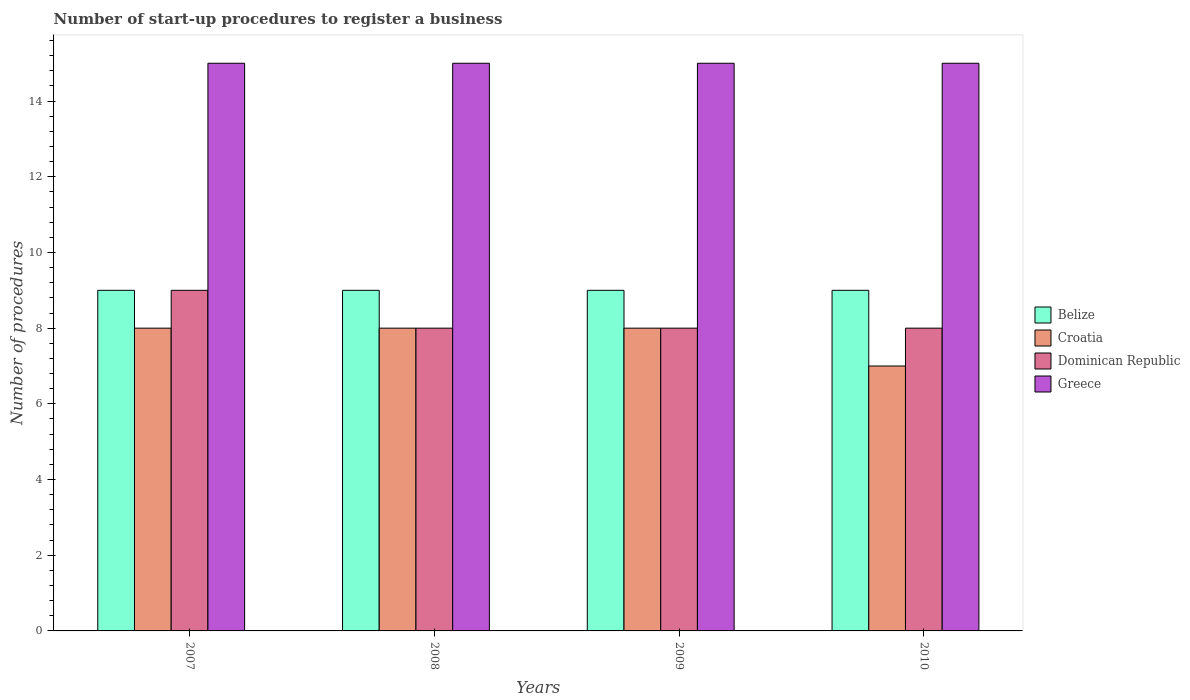How many different coloured bars are there?
Offer a terse response. 4. How many groups of bars are there?
Provide a short and direct response. 4. Are the number of bars per tick equal to the number of legend labels?
Ensure brevity in your answer.  Yes. Are the number of bars on each tick of the X-axis equal?
Provide a short and direct response. Yes. How many bars are there on the 4th tick from the right?
Ensure brevity in your answer.  4. What is the label of the 2nd group of bars from the left?
Keep it short and to the point. 2008. What is the number of procedures required to register a business in Croatia in 2009?
Provide a short and direct response. 8. Across all years, what is the maximum number of procedures required to register a business in Belize?
Provide a short and direct response. 9. Across all years, what is the minimum number of procedures required to register a business in Dominican Republic?
Provide a short and direct response. 8. In which year was the number of procedures required to register a business in Belize maximum?
Make the answer very short. 2007. What is the total number of procedures required to register a business in Greece in the graph?
Ensure brevity in your answer.  60. What is the average number of procedures required to register a business in Dominican Republic per year?
Provide a succinct answer. 8.25. In the year 2009, what is the difference between the number of procedures required to register a business in Greece and number of procedures required to register a business in Belize?
Make the answer very short. 6. In how many years, is the number of procedures required to register a business in Greece greater than 14?
Ensure brevity in your answer.  4. What is the ratio of the number of procedures required to register a business in Belize in 2009 to that in 2010?
Your answer should be compact. 1. Is the difference between the number of procedures required to register a business in Greece in 2007 and 2010 greater than the difference between the number of procedures required to register a business in Belize in 2007 and 2010?
Your response must be concise. No. What is the difference between the highest and the second highest number of procedures required to register a business in Greece?
Offer a very short reply. 0. What is the difference between the highest and the lowest number of procedures required to register a business in Croatia?
Provide a short and direct response. 1. In how many years, is the number of procedures required to register a business in Greece greater than the average number of procedures required to register a business in Greece taken over all years?
Provide a short and direct response. 0. Is the sum of the number of procedures required to register a business in Belize in 2008 and 2010 greater than the maximum number of procedures required to register a business in Dominican Republic across all years?
Offer a very short reply. Yes. What does the 2nd bar from the left in 2009 represents?
Offer a very short reply. Croatia. What does the 3rd bar from the right in 2008 represents?
Your answer should be compact. Croatia. Is it the case that in every year, the sum of the number of procedures required to register a business in Dominican Republic and number of procedures required to register a business in Croatia is greater than the number of procedures required to register a business in Belize?
Keep it short and to the point. Yes. How many bars are there?
Offer a terse response. 16. Are all the bars in the graph horizontal?
Provide a succinct answer. No. What is the difference between two consecutive major ticks on the Y-axis?
Your response must be concise. 2. Does the graph contain grids?
Ensure brevity in your answer.  No. How are the legend labels stacked?
Offer a very short reply. Vertical. What is the title of the graph?
Provide a short and direct response. Number of start-up procedures to register a business. What is the label or title of the Y-axis?
Offer a very short reply. Number of procedures. What is the Number of procedures in Croatia in 2007?
Your response must be concise. 8. What is the Number of procedures in Dominican Republic in 2007?
Your response must be concise. 9. What is the Number of procedures of Greece in 2007?
Offer a terse response. 15. What is the Number of procedures of Belize in 2008?
Offer a very short reply. 9. What is the Number of procedures in Dominican Republic in 2008?
Your answer should be very brief. 8. What is the Number of procedures of Greece in 2008?
Ensure brevity in your answer.  15. What is the Number of procedures in Croatia in 2009?
Offer a terse response. 8. What is the Number of procedures in Dominican Republic in 2009?
Your answer should be very brief. 8. What is the Number of procedures in Greece in 2009?
Offer a very short reply. 15. What is the Number of procedures of Belize in 2010?
Your answer should be compact. 9. What is the Number of procedures of Croatia in 2010?
Offer a very short reply. 7. What is the Number of procedures of Dominican Republic in 2010?
Offer a terse response. 8. What is the Number of procedures of Greece in 2010?
Provide a short and direct response. 15. Across all years, what is the maximum Number of procedures in Belize?
Your answer should be very brief. 9. Across all years, what is the maximum Number of procedures of Croatia?
Offer a terse response. 8. Across all years, what is the minimum Number of procedures of Belize?
Offer a very short reply. 9. Across all years, what is the minimum Number of procedures in Croatia?
Offer a terse response. 7. What is the total Number of procedures of Greece in the graph?
Your response must be concise. 60. What is the difference between the Number of procedures of Dominican Republic in 2007 and that in 2008?
Ensure brevity in your answer.  1. What is the difference between the Number of procedures of Belize in 2007 and that in 2009?
Your response must be concise. 0. What is the difference between the Number of procedures of Croatia in 2007 and that in 2009?
Your answer should be compact. 0. What is the difference between the Number of procedures in Greece in 2007 and that in 2009?
Provide a succinct answer. 0. What is the difference between the Number of procedures in Dominican Republic in 2007 and that in 2010?
Offer a terse response. 1. What is the difference between the Number of procedures in Greece in 2007 and that in 2010?
Your answer should be compact. 0. What is the difference between the Number of procedures in Greece in 2008 and that in 2009?
Your answer should be very brief. 0. What is the difference between the Number of procedures in Belize in 2008 and that in 2010?
Make the answer very short. 0. What is the difference between the Number of procedures of Dominican Republic in 2008 and that in 2010?
Make the answer very short. 0. What is the difference between the Number of procedures of Greece in 2009 and that in 2010?
Provide a succinct answer. 0. What is the difference between the Number of procedures of Belize in 2007 and the Number of procedures of Croatia in 2008?
Your answer should be very brief. 1. What is the difference between the Number of procedures in Belize in 2007 and the Number of procedures in Dominican Republic in 2008?
Your answer should be very brief. 1. What is the difference between the Number of procedures of Croatia in 2007 and the Number of procedures of Greece in 2008?
Your response must be concise. -7. What is the difference between the Number of procedures of Belize in 2007 and the Number of procedures of Dominican Republic in 2009?
Your response must be concise. 1. What is the difference between the Number of procedures of Croatia in 2007 and the Number of procedures of Greece in 2009?
Your answer should be very brief. -7. What is the difference between the Number of procedures of Dominican Republic in 2007 and the Number of procedures of Greece in 2009?
Provide a succinct answer. -6. What is the difference between the Number of procedures of Belize in 2007 and the Number of procedures of Croatia in 2010?
Provide a succinct answer. 2. What is the difference between the Number of procedures in Belize in 2007 and the Number of procedures in Dominican Republic in 2010?
Provide a succinct answer. 1. What is the difference between the Number of procedures in Croatia in 2007 and the Number of procedures in Dominican Republic in 2010?
Provide a succinct answer. 0. What is the difference between the Number of procedures of Belize in 2008 and the Number of procedures of Croatia in 2009?
Provide a short and direct response. 1. What is the difference between the Number of procedures in Belize in 2008 and the Number of procedures in Dominican Republic in 2009?
Your answer should be very brief. 1. What is the difference between the Number of procedures in Belize in 2008 and the Number of procedures in Greece in 2009?
Give a very brief answer. -6. What is the difference between the Number of procedures of Croatia in 2008 and the Number of procedures of Dominican Republic in 2009?
Offer a terse response. 0. What is the difference between the Number of procedures of Croatia in 2008 and the Number of procedures of Greece in 2009?
Offer a terse response. -7. What is the difference between the Number of procedures in Dominican Republic in 2008 and the Number of procedures in Greece in 2009?
Give a very brief answer. -7. What is the difference between the Number of procedures in Belize in 2008 and the Number of procedures in Croatia in 2010?
Your response must be concise. 2. What is the difference between the Number of procedures in Belize in 2008 and the Number of procedures in Greece in 2010?
Offer a terse response. -6. What is the difference between the Number of procedures of Croatia in 2008 and the Number of procedures of Greece in 2010?
Keep it short and to the point. -7. What is the difference between the Number of procedures in Belize in 2009 and the Number of procedures in Dominican Republic in 2010?
Ensure brevity in your answer.  1. What is the difference between the Number of procedures in Dominican Republic in 2009 and the Number of procedures in Greece in 2010?
Make the answer very short. -7. What is the average Number of procedures in Croatia per year?
Provide a short and direct response. 7.75. What is the average Number of procedures of Dominican Republic per year?
Keep it short and to the point. 8.25. In the year 2007, what is the difference between the Number of procedures in Belize and Number of procedures in Croatia?
Your answer should be very brief. 1. In the year 2007, what is the difference between the Number of procedures in Belize and Number of procedures in Greece?
Make the answer very short. -6. In the year 2007, what is the difference between the Number of procedures of Croatia and Number of procedures of Greece?
Keep it short and to the point. -7. In the year 2009, what is the difference between the Number of procedures of Belize and Number of procedures of Croatia?
Make the answer very short. 1. In the year 2009, what is the difference between the Number of procedures in Belize and Number of procedures in Dominican Republic?
Keep it short and to the point. 1. In the year 2009, what is the difference between the Number of procedures in Croatia and Number of procedures in Greece?
Keep it short and to the point. -7. In the year 2010, what is the difference between the Number of procedures of Belize and Number of procedures of Croatia?
Offer a very short reply. 2. In the year 2010, what is the difference between the Number of procedures in Croatia and Number of procedures in Dominican Republic?
Offer a terse response. -1. In the year 2010, what is the difference between the Number of procedures in Dominican Republic and Number of procedures in Greece?
Your answer should be compact. -7. What is the ratio of the Number of procedures in Belize in 2007 to that in 2009?
Keep it short and to the point. 1. What is the ratio of the Number of procedures of Croatia in 2007 to that in 2010?
Your answer should be compact. 1.14. What is the ratio of the Number of procedures in Dominican Republic in 2007 to that in 2010?
Offer a terse response. 1.12. What is the ratio of the Number of procedures of Croatia in 2008 to that in 2010?
Make the answer very short. 1.14. What is the ratio of the Number of procedures of Dominican Republic in 2008 to that in 2010?
Ensure brevity in your answer.  1. What is the ratio of the Number of procedures of Belize in 2009 to that in 2010?
Provide a succinct answer. 1. What is the ratio of the Number of procedures in Croatia in 2009 to that in 2010?
Make the answer very short. 1.14. What is the ratio of the Number of procedures of Dominican Republic in 2009 to that in 2010?
Keep it short and to the point. 1. What is the ratio of the Number of procedures of Greece in 2009 to that in 2010?
Ensure brevity in your answer.  1. What is the difference between the highest and the second highest Number of procedures of Belize?
Ensure brevity in your answer.  0. What is the difference between the highest and the second highest Number of procedures of Croatia?
Your answer should be very brief. 0. What is the difference between the highest and the second highest Number of procedures in Greece?
Make the answer very short. 0. What is the difference between the highest and the lowest Number of procedures in Croatia?
Make the answer very short. 1. What is the difference between the highest and the lowest Number of procedures of Greece?
Your answer should be very brief. 0. 